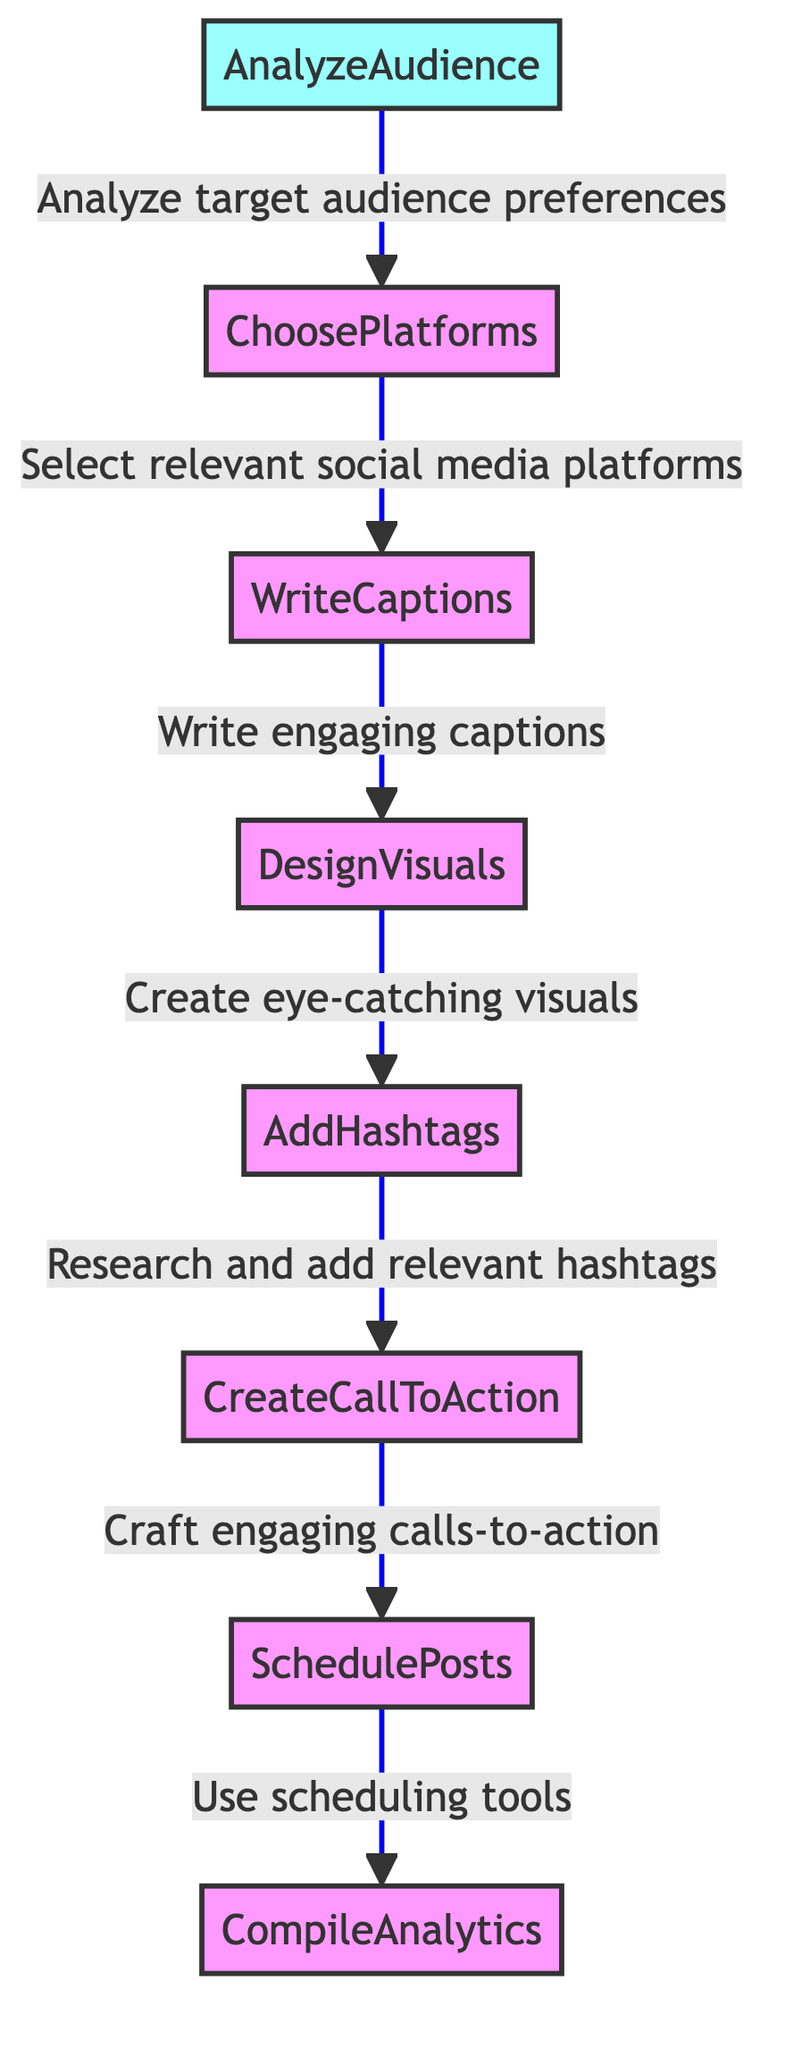what is the first step in the flowchart? The first step listed at the bottom of the flowchart is "AnalyzeAudience." It is the starting point for the entire process of generating social media content.
Answer: AnalyzeAudience how many steps are there in the flowchart? By counting the steps in the flowchart, we find there are a total of eight distinct steps from "AnalyzeAudience" to "CompileAnalytics." Each step represents a specific action in the process.
Answer: 8 what is the relationship between 'AddHashtags' and 'CreateCallToAction'? "AddHashtags" is a step that directly follows "CreateCallToAction" in the flowchart. This indicates that after crafting calls-to-action, one should research and add relevant hashtags.
Answer: AddHashtags follows CreateCallToAction which step requires the use of tools like Buffer or Hootsuite? The step where the use of tools like Buffer or Hootsuite is required is "SchedulePosts." This step emphasizes the scheduling of posts for social media content distribution.
Answer: SchedulePosts what comes after 'WriteCaptions'? The step that comes after "WriteCaptions" in the flowchart is "DesignVisuals." This indicates that after writing engaging captions, the next action is to create eye-catching visuals.
Answer: DesignVisuals which step involves analyzing audience preferences? The step that involves analyzing audience preferences is "AnalyzeAudience." This step is crucial as it sets the direction for tailoring content to the target audience.
Answer: AnalyzeAudience what is the final step in the process? The final step in the flowchart is "CompileAnalytics." This step involves compiling performance analytics from all platforms, concluding the content promotion process.
Answer: CompileAnalytics how do the steps flow from 'AnalyzeAudience' to 'CompileAnalytics'? The flow starts at "AnalyzeAudience," which leads to "ChoosePlatforms," then "WriteCaptions," followed by "DesignVisuals," then "AddHashtags," then "CreateCallToAction," followed by "SchedulePosts," and finally results in "CompileAnalytics." This stepwise progression outlines how each action builds on the previous one.
Answer: Stepwise progression from AnalyzeAudience to CompileAnalytics 